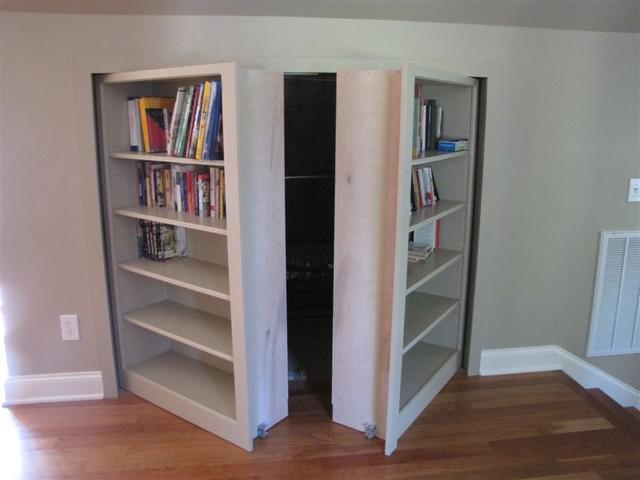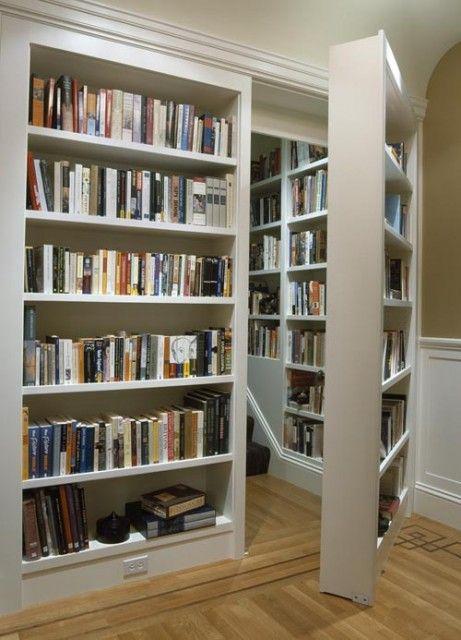The first image is the image on the left, the second image is the image on the right. Examine the images to the left and right. Is the description "There is at least one chair near the bookshelves." accurate? Answer yes or no. No. 